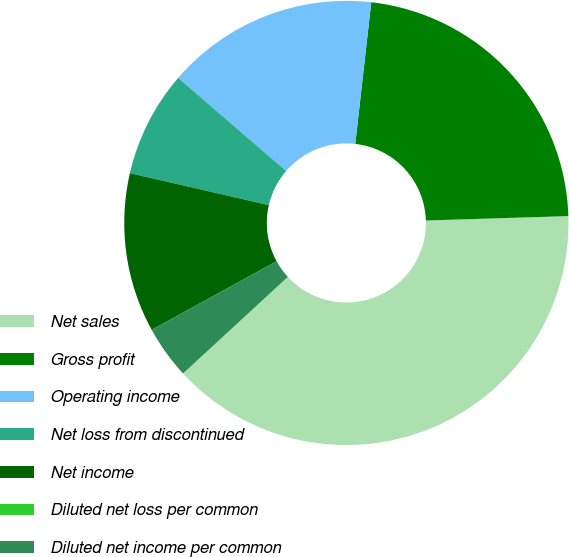<chart> <loc_0><loc_0><loc_500><loc_500><pie_chart><fcel>Net sales<fcel>Gross profit<fcel>Operating income<fcel>Net loss from discontinued<fcel>Net income<fcel>Diluted net loss per common<fcel>Diluted net income per common<nl><fcel>38.64%<fcel>22.72%<fcel>15.46%<fcel>7.73%<fcel>11.59%<fcel>0.0%<fcel>3.86%<nl></chart> 